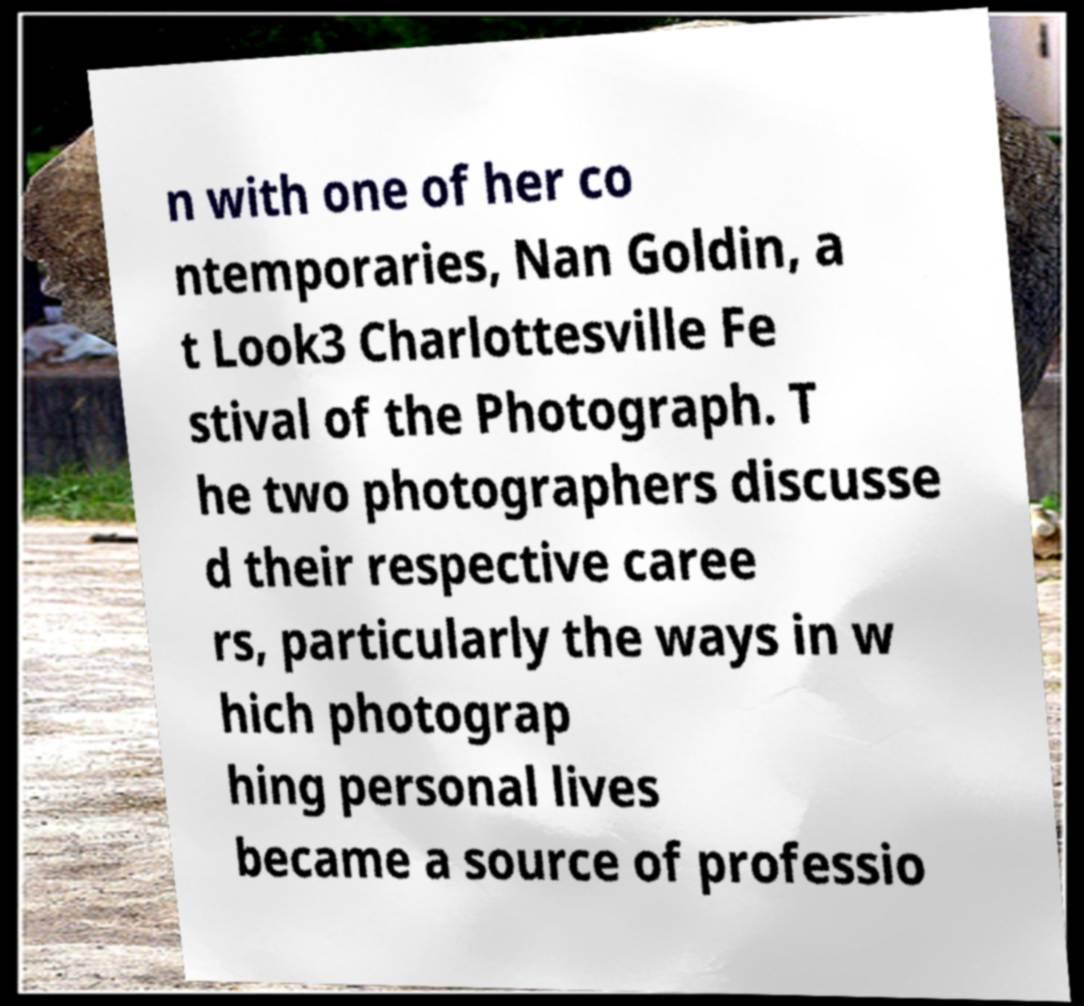Please read and relay the text visible in this image. What does it say? n with one of her co ntemporaries, Nan Goldin, a t Look3 Charlottesville Fe stival of the Photograph. T he two photographers discusse d their respective caree rs, particularly the ways in w hich photograp hing personal lives became a source of professio 